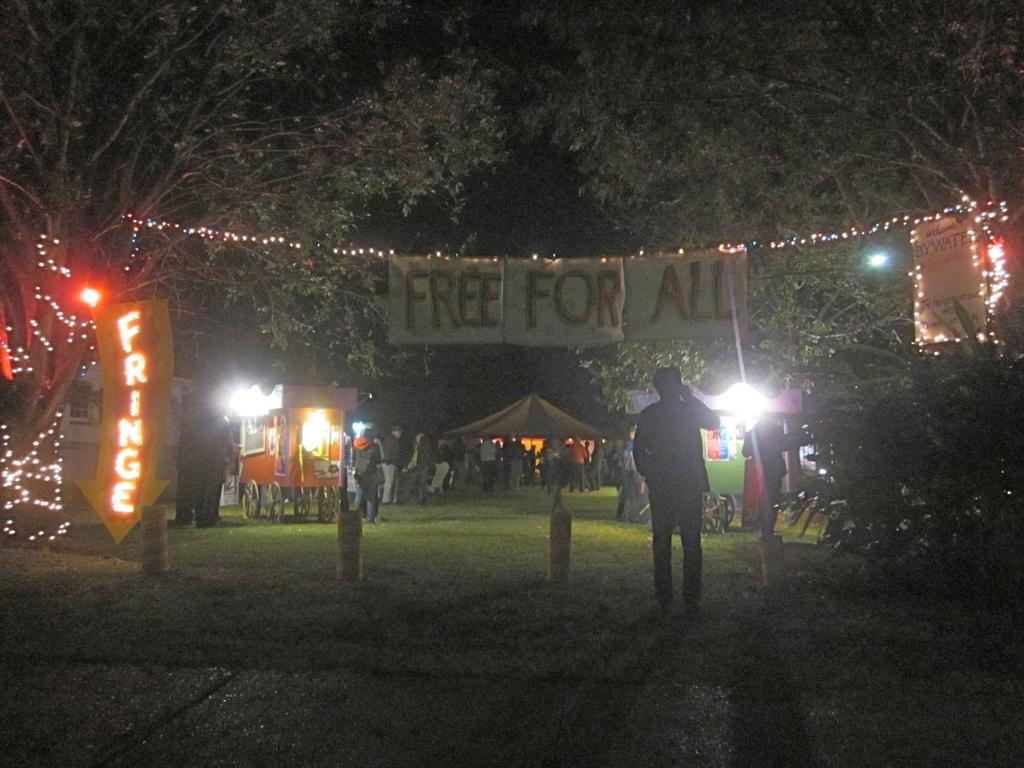What is the main subject of the image? There is a person standing in the image. What can be seen in the background of the image? There are stalls, a yellow-colored board, a tent, lights, and trees visible in the background. Can you describe the color of the board in the background? The board in the background is yellow-colored. What type of vegetation is present in the background of the image? Trees are present in the background of the image. What type of pollution can be seen in the image? There is no pollution visible in the image. Can you describe the grass in the image? There is no grass present in the image. 